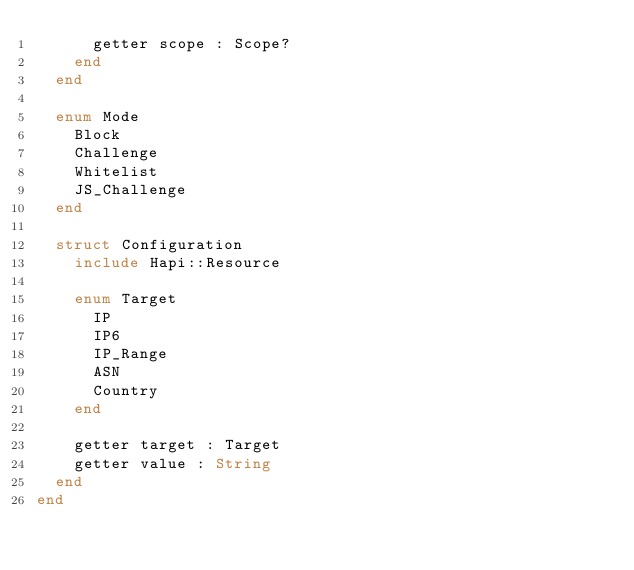<code> <loc_0><loc_0><loc_500><loc_500><_Crystal_>      getter scope : Scope?
    end
  end

  enum Mode
    Block
    Challenge
    Whitelist
    JS_Challenge
  end

  struct Configuration
    include Hapi::Resource

    enum Target
      IP
      IP6
      IP_Range
      ASN
      Country
    end

    getter target : Target
    getter value : String
  end
end
</code> 